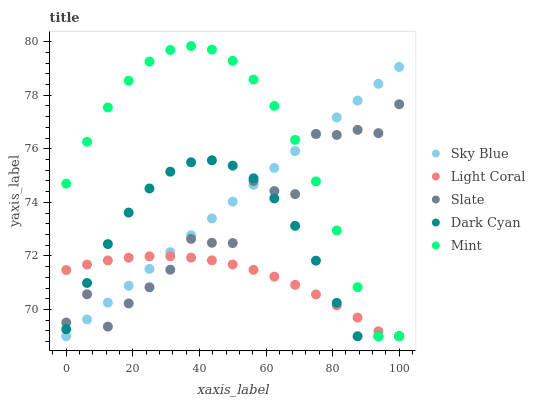Does Light Coral have the minimum area under the curve?
Answer yes or no. Yes. Does Mint have the maximum area under the curve?
Answer yes or no. Yes. Does Sky Blue have the minimum area under the curve?
Answer yes or no. No. Does Sky Blue have the maximum area under the curve?
Answer yes or no. No. Is Sky Blue the smoothest?
Answer yes or no. Yes. Is Slate the roughest?
Answer yes or no. Yes. Is Slate the smoothest?
Answer yes or no. No. Is Sky Blue the roughest?
Answer yes or no. No. Does Light Coral have the lowest value?
Answer yes or no. Yes. Does Slate have the lowest value?
Answer yes or no. No. Does Mint have the highest value?
Answer yes or no. Yes. Does Sky Blue have the highest value?
Answer yes or no. No. Does Sky Blue intersect Light Coral?
Answer yes or no. Yes. Is Sky Blue less than Light Coral?
Answer yes or no. No. Is Sky Blue greater than Light Coral?
Answer yes or no. No. 